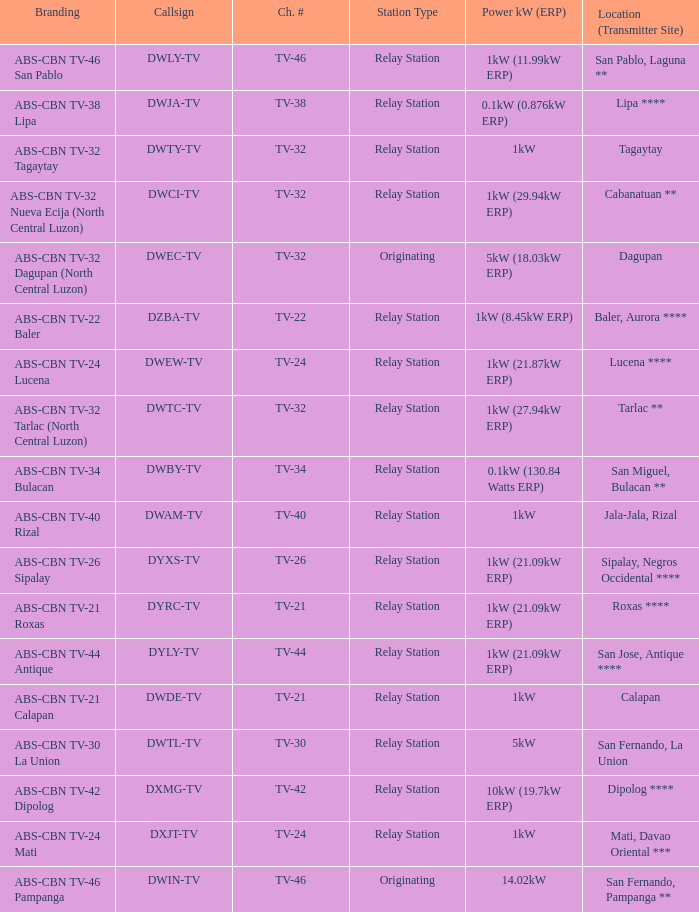The location (transmitter site) San Fernando, Pampanga ** has what Power kW (ERP)? 14.02kW. 